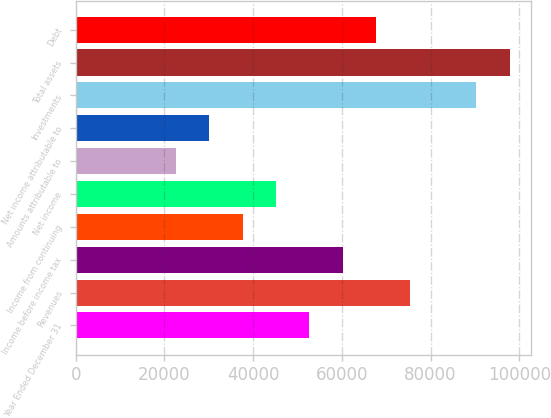Convert chart to OTSL. <chart><loc_0><loc_0><loc_500><loc_500><bar_chart><fcel>Year Ended December 31<fcel>Revenues<fcel>Income before income tax<fcel>Income from continuing<fcel>Net income<fcel>Amounts attributable to<fcel>Net income attributable to<fcel>Investments<fcel>Total assets<fcel>Debt<nl><fcel>52687.7<fcel>75268<fcel>60214.5<fcel>37634.1<fcel>45160.9<fcel>22580.6<fcel>30107.4<fcel>90321.6<fcel>97848.3<fcel>67741.2<nl></chart> 